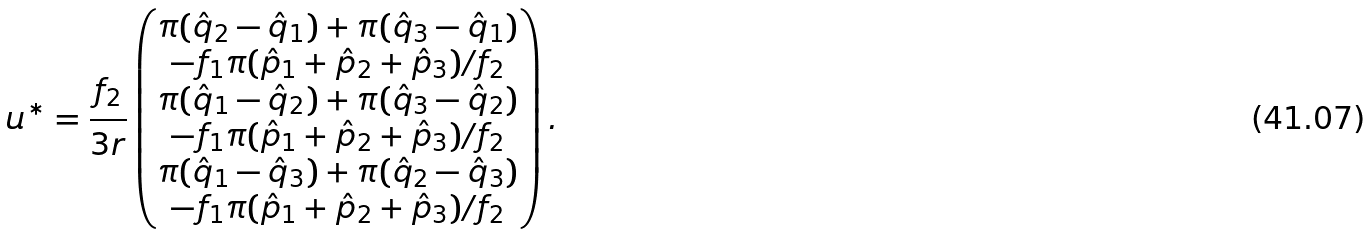<formula> <loc_0><loc_0><loc_500><loc_500>u ^ { * } = \frac { f _ { 2 } } { 3 r } \begin{pmatrix} \pi ( \hat { q } _ { 2 } - \hat { q } _ { 1 } ) + \pi ( \hat { q } _ { 3 } - \hat { q } _ { 1 } ) \\ - f _ { 1 } \pi ( \hat { p } _ { 1 } + \hat { p } _ { 2 } + \hat { p } _ { 3 } ) / f _ { 2 } \\ \pi ( \hat { q } _ { 1 } - \hat { q } _ { 2 } ) + \pi ( \hat { q } _ { 3 } - \hat { q } _ { 2 } ) \\ - f _ { 1 } \pi ( \hat { p } _ { 1 } + \hat { p } _ { 2 } + \hat { p } _ { 3 } ) / f _ { 2 } \\ \pi ( \hat { q } _ { 1 } - \hat { q } _ { 3 } ) + \pi ( \hat { q } _ { 2 } - \hat { q } _ { 3 } ) \\ - f _ { 1 } \pi ( \hat { p } _ { 1 } + \hat { p } _ { 2 } + \hat { p } _ { 3 } ) / f _ { 2 } \\ \end{pmatrix} .</formula> 